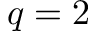<formula> <loc_0><loc_0><loc_500><loc_500>q = 2</formula> 